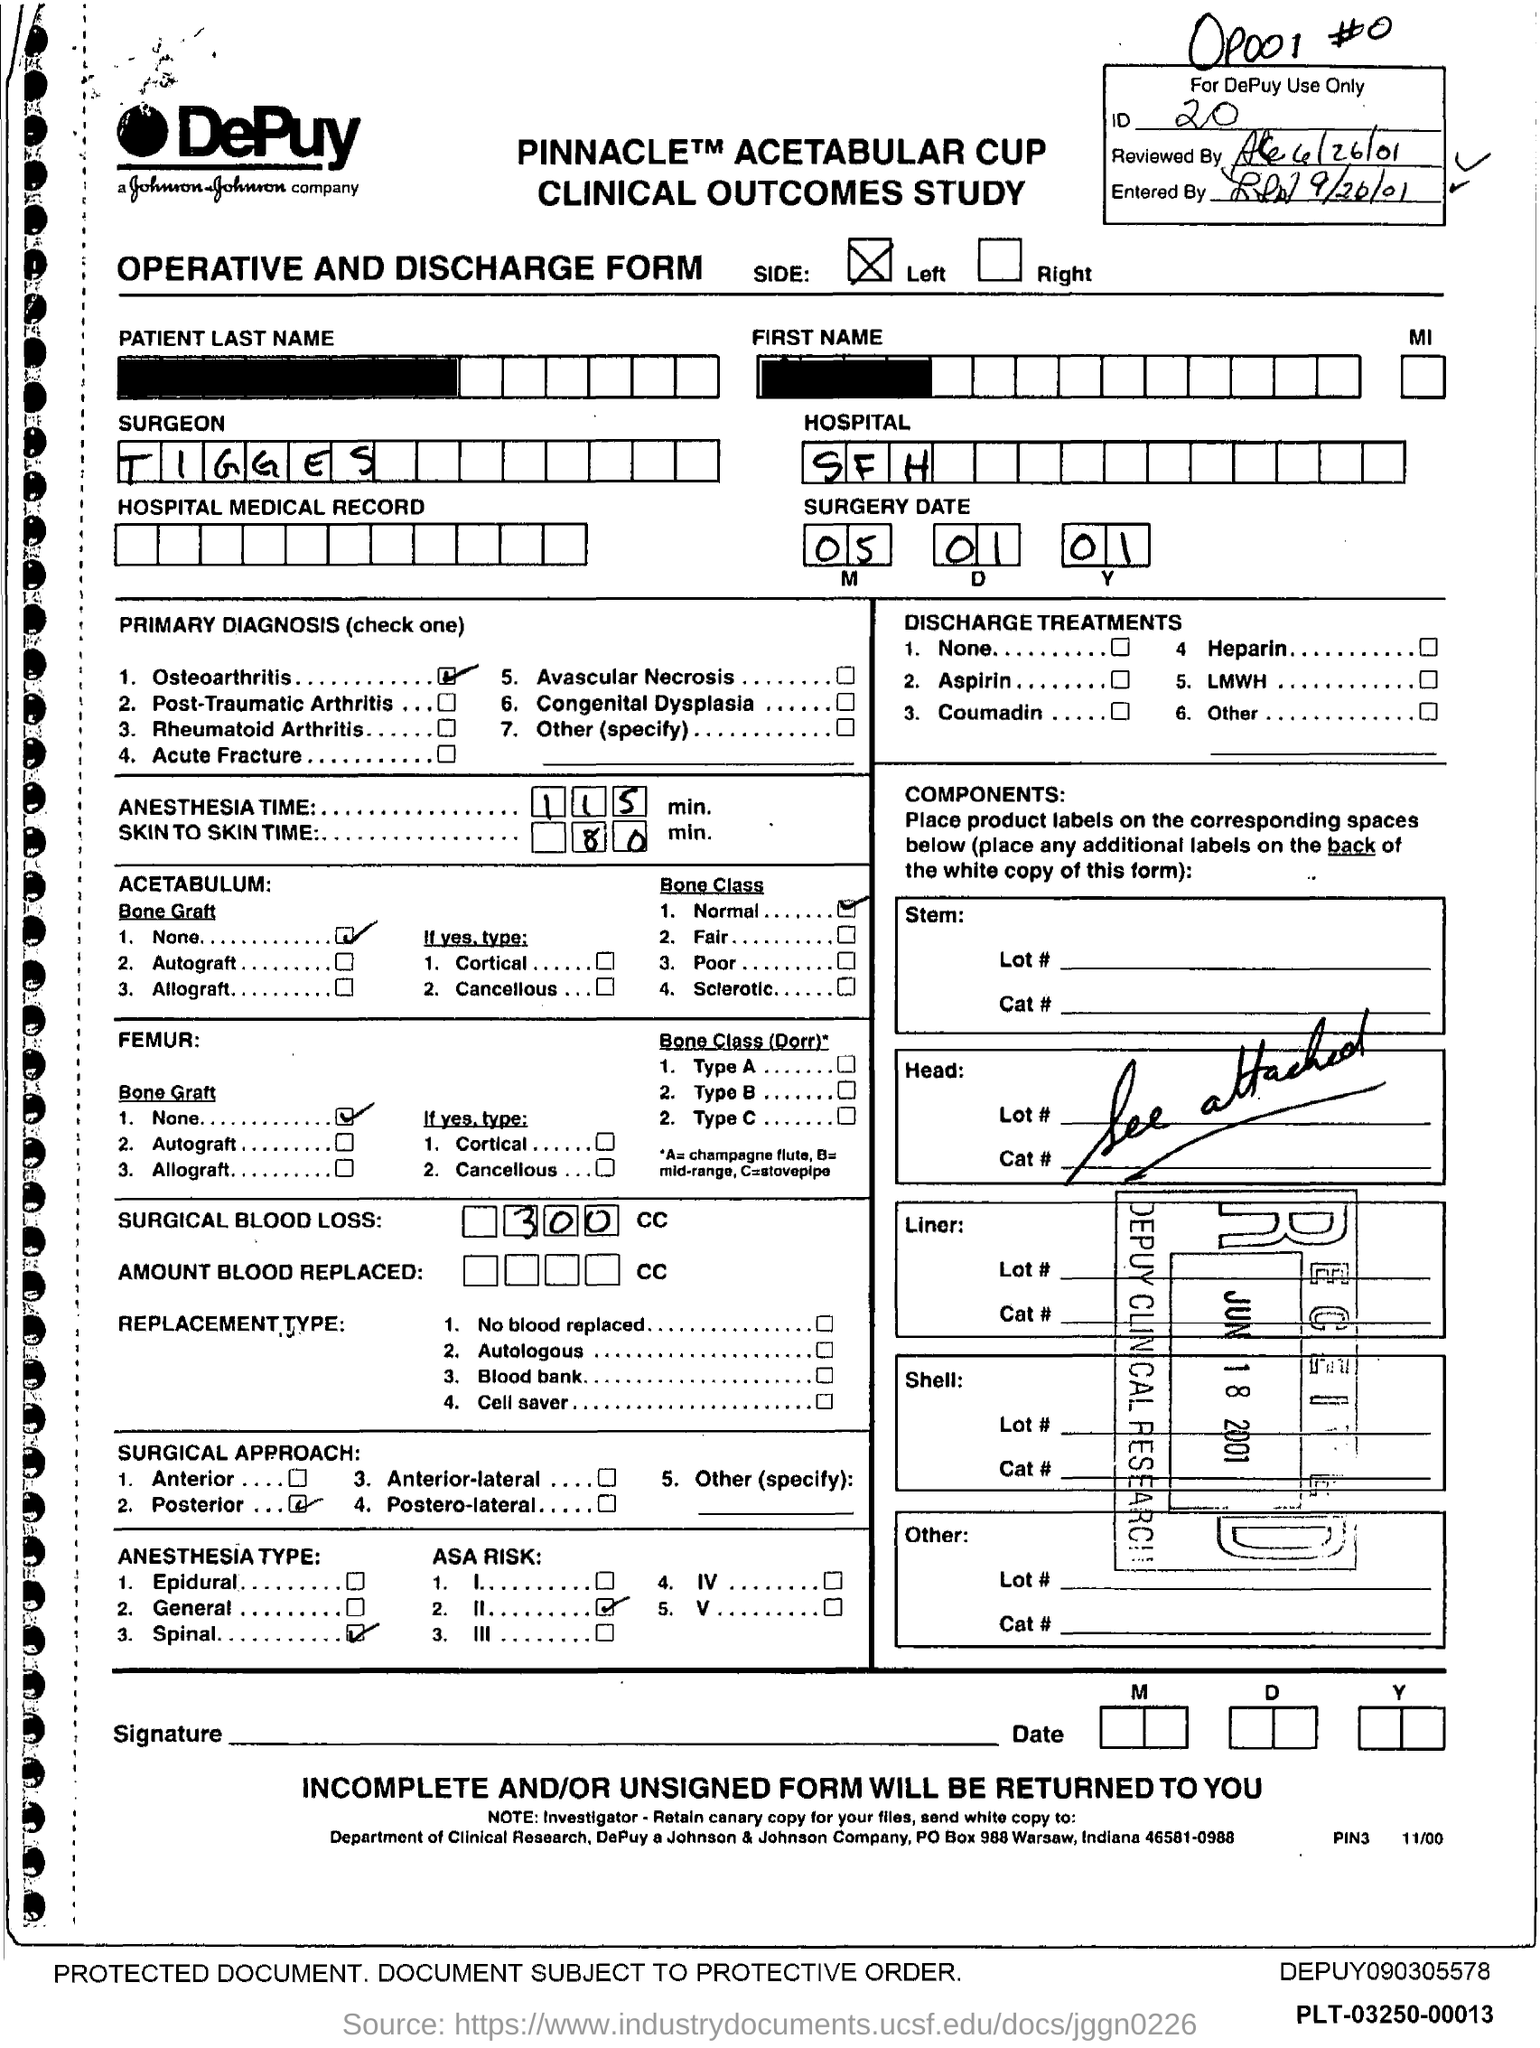What is the ID mentioned in the form?
Your answer should be very brief. 20. What type of form is given here?
Your answer should be very brief. OPERATIVE AND DISCHARGE. What is the surgery date mentioned in the form?
Keep it short and to the point. 05 01 01. What is the surgeon's name mentioned in the form?
Provide a succinct answer. TIGGES. In which hospital is the surgery done?
Provide a short and direct response. SFH. What is the primary diagnosis of the surgery?
Offer a terse response. Osteoarthritis. What is the anesthesia time for the surgery?
Offer a terse response. 115 min. What is the amount of surgical blood loss?
Your answer should be compact. 300 CC. Which surgical approach is used for the surgery?
Your response must be concise. Posterior. 